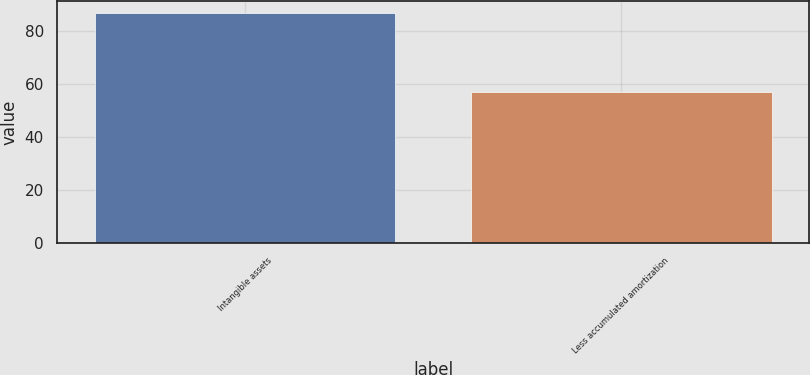Convert chart to OTSL. <chart><loc_0><loc_0><loc_500><loc_500><bar_chart><fcel>Intangible assets<fcel>Less accumulated amortization<nl><fcel>87<fcel>57<nl></chart> 